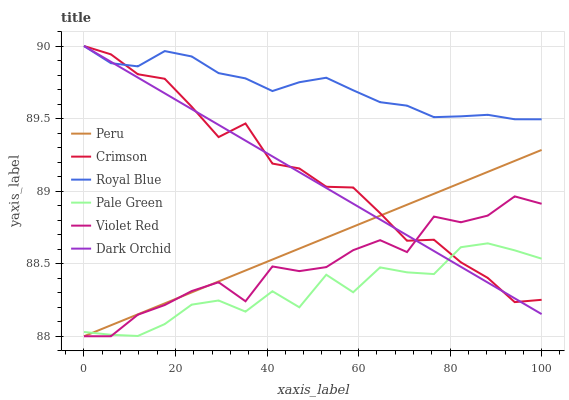Does Dark Orchid have the minimum area under the curve?
Answer yes or no. No. Does Dark Orchid have the maximum area under the curve?
Answer yes or no. No. Is Dark Orchid the smoothest?
Answer yes or no. No. Is Dark Orchid the roughest?
Answer yes or no. No. Does Dark Orchid have the lowest value?
Answer yes or no. No. Does Pale Green have the highest value?
Answer yes or no. No. Is Peru less than Royal Blue?
Answer yes or no. Yes. Is Royal Blue greater than Violet Red?
Answer yes or no. Yes. Does Peru intersect Royal Blue?
Answer yes or no. No. 